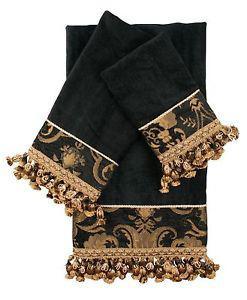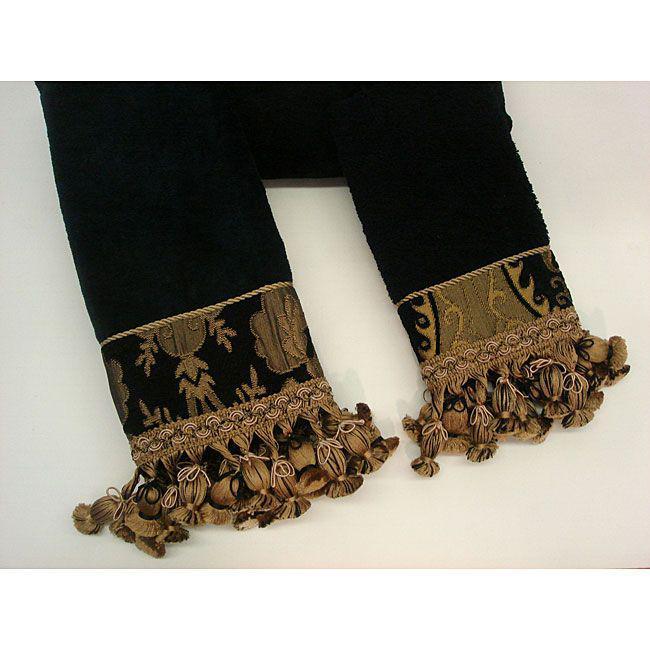The first image is the image on the left, the second image is the image on the right. Assess this claim about the two images: "All towels are edged with braid trim or all towels are edged with ball trim.". Correct or not? Answer yes or no. Yes. The first image is the image on the left, the second image is the image on the right. Examine the images to the left and right. Is the description "There are towels with flanges on the bottom facing downward." accurate? Answer yes or no. Yes. 